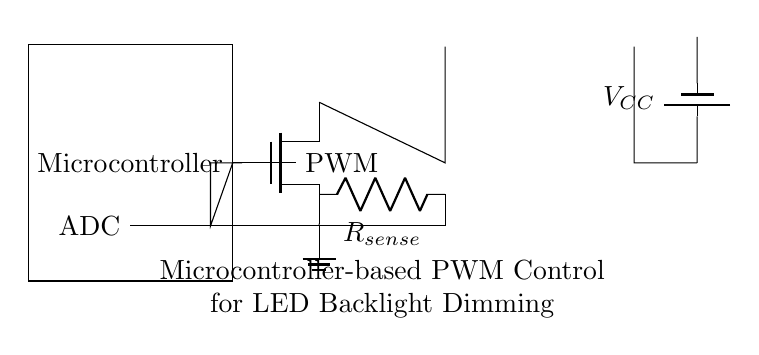What component regulates LED brightness? The microcontroller generates the PWM signal, which controls the MOSFET's switching, thus regulating the LED brightness based on the duty cycle of the PWM signal.
Answer: Microcontroller What is the purpose of the current sense resistor? The current sense resistor provides feedback to the microcontroller by measuring the current flowing through the LED array, allowing it to make adjustments for accurate dimming control.
Answer: Measure current What type of transistor is used in this circuit? The circuit utilizes an NMOS transistor, which is suitable for controlling the current to the LED due to its enhanced performance characteristics for switching applications.
Answer: NMOS Which component provides the power supply for the LEDs? The power supply is provided by the battery, which delivers the required voltage for the LED array operation.
Answer: Battery What is the signal type sent from the microcontroller to the MOSFET? The microcontroller sends a PWM signal to the MOSFET, which allows for effective dimming of the LED backlight by rapidly turning the LED circuit on and off.
Answer: PWM How does the feedback mechanism work in this circuit? The feedback mechanism works by sensing the current through the sense resistor, which is then fed back to the ADC in the microcontroller. This feedback allows the microcontroller to adjust the PWM signal accordingly for optimal performance.
Answer: Feedback to ADC 